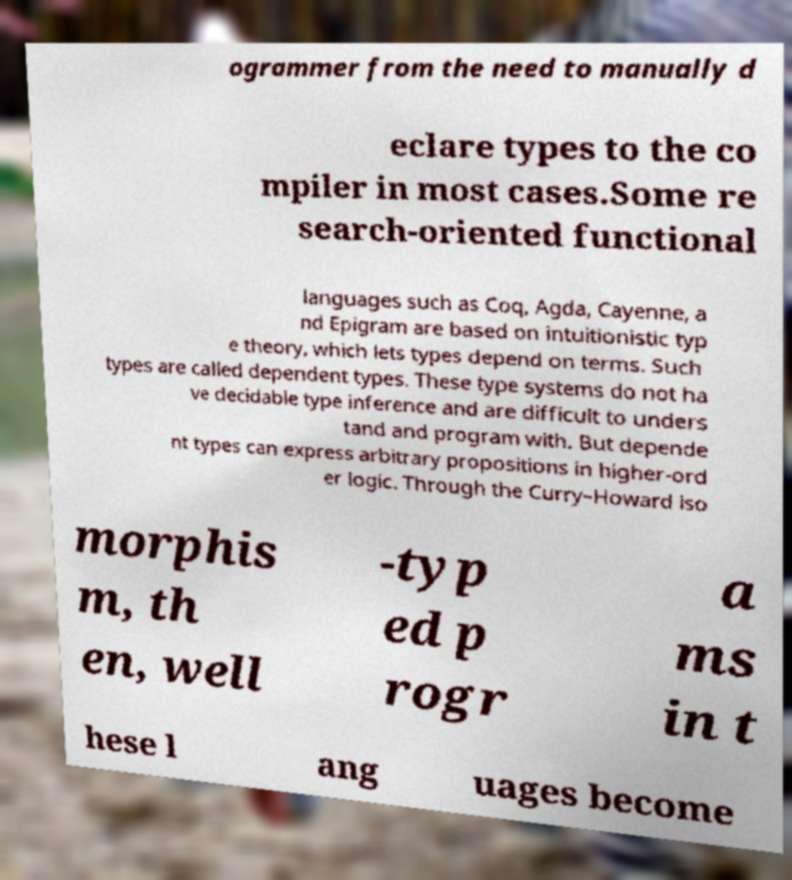For documentation purposes, I need the text within this image transcribed. Could you provide that? ogrammer from the need to manually d eclare types to the co mpiler in most cases.Some re search-oriented functional languages such as Coq, Agda, Cayenne, a nd Epigram are based on intuitionistic typ e theory, which lets types depend on terms. Such types are called dependent types. These type systems do not ha ve decidable type inference and are difficult to unders tand and program with. But depende nt types can express arbitrary propositions in higher-ord er logic. Through the Curry–Howard iso morphis m, th en, well -typ ed p rogr a ms in t hese l ang uages become 